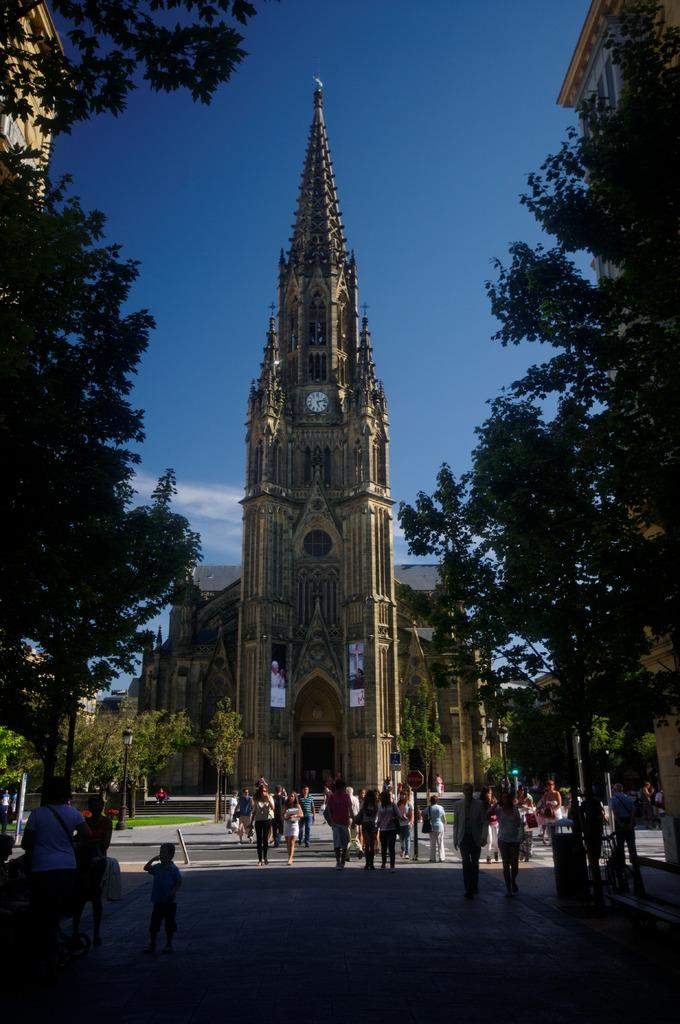What are the people in the image doing? There are many people walking in the image. What can be seen in the background of the image? There is a building and trees in the background of the image. What is visible in the sky in the image? The sky is visible in the background of the image. What feature is present on the building in the image? There is a clock on the building. What type of art can be seen on the nails of the people in the image? There is no mention of nails or art in the image; it features people walking and a building with a clock. 